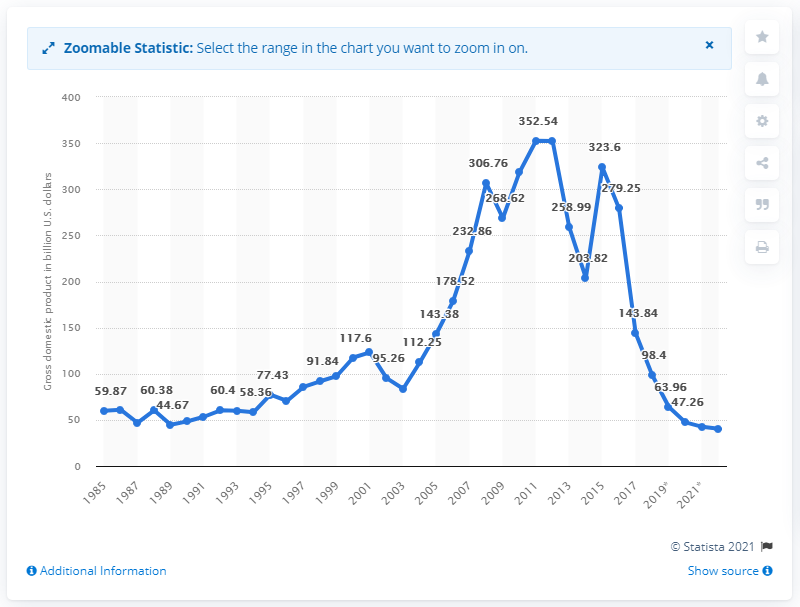Point out several critical features in this image. Venezuela's GDP in 2018 was 98.4%. 